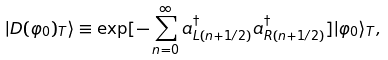<formula> <loc_0><loc_0><loc_500><loc_500>| D ( \varphi _ { 0 } ) _ { T } \rangle \equiv \exp [ { - \sum _ { n = 0 } ^ { \infty } a _ { L ( n + 1 / 2 ) } ^ { \dagger } a _ { R ( n + 1 / 2 ) } ^ { \dagger } } ] | \varphi _ { 0 } \rangle _ { T } ,</formula> 